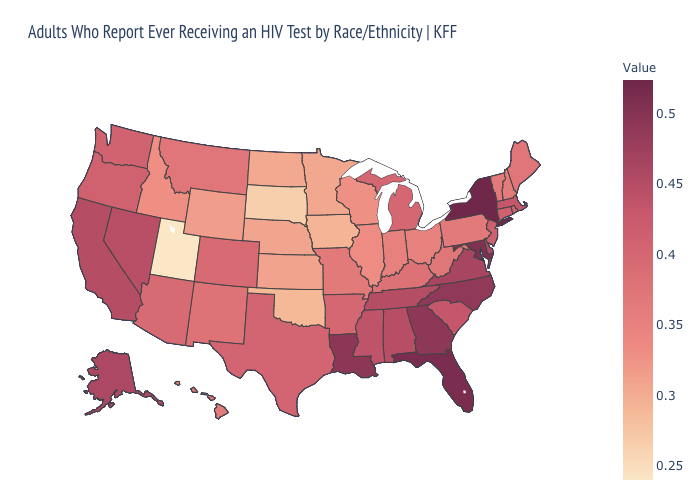Is the legend a continuous bar?
Short answer required. Yes. Does the map have missing data?
Write a very short answer. No. Does New Mexico have the lowest value in the West?
Give a very brief answer. No. Does Washington have the highest value in the USA?
Short answer required. No. Which states have the lowest value in the USA?
Write a very short answer. Utah. Which states have the lowest value in the USA?
Quick response, please. Utah. Which states have the highest value in the USA?
Keep it brief. New York. Which states hav the highest value in the MidWest?
Answer briefly. Michigan. 